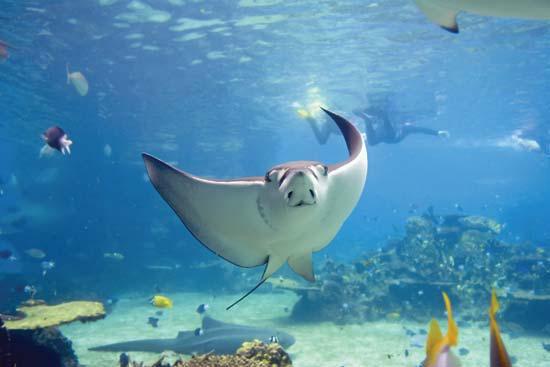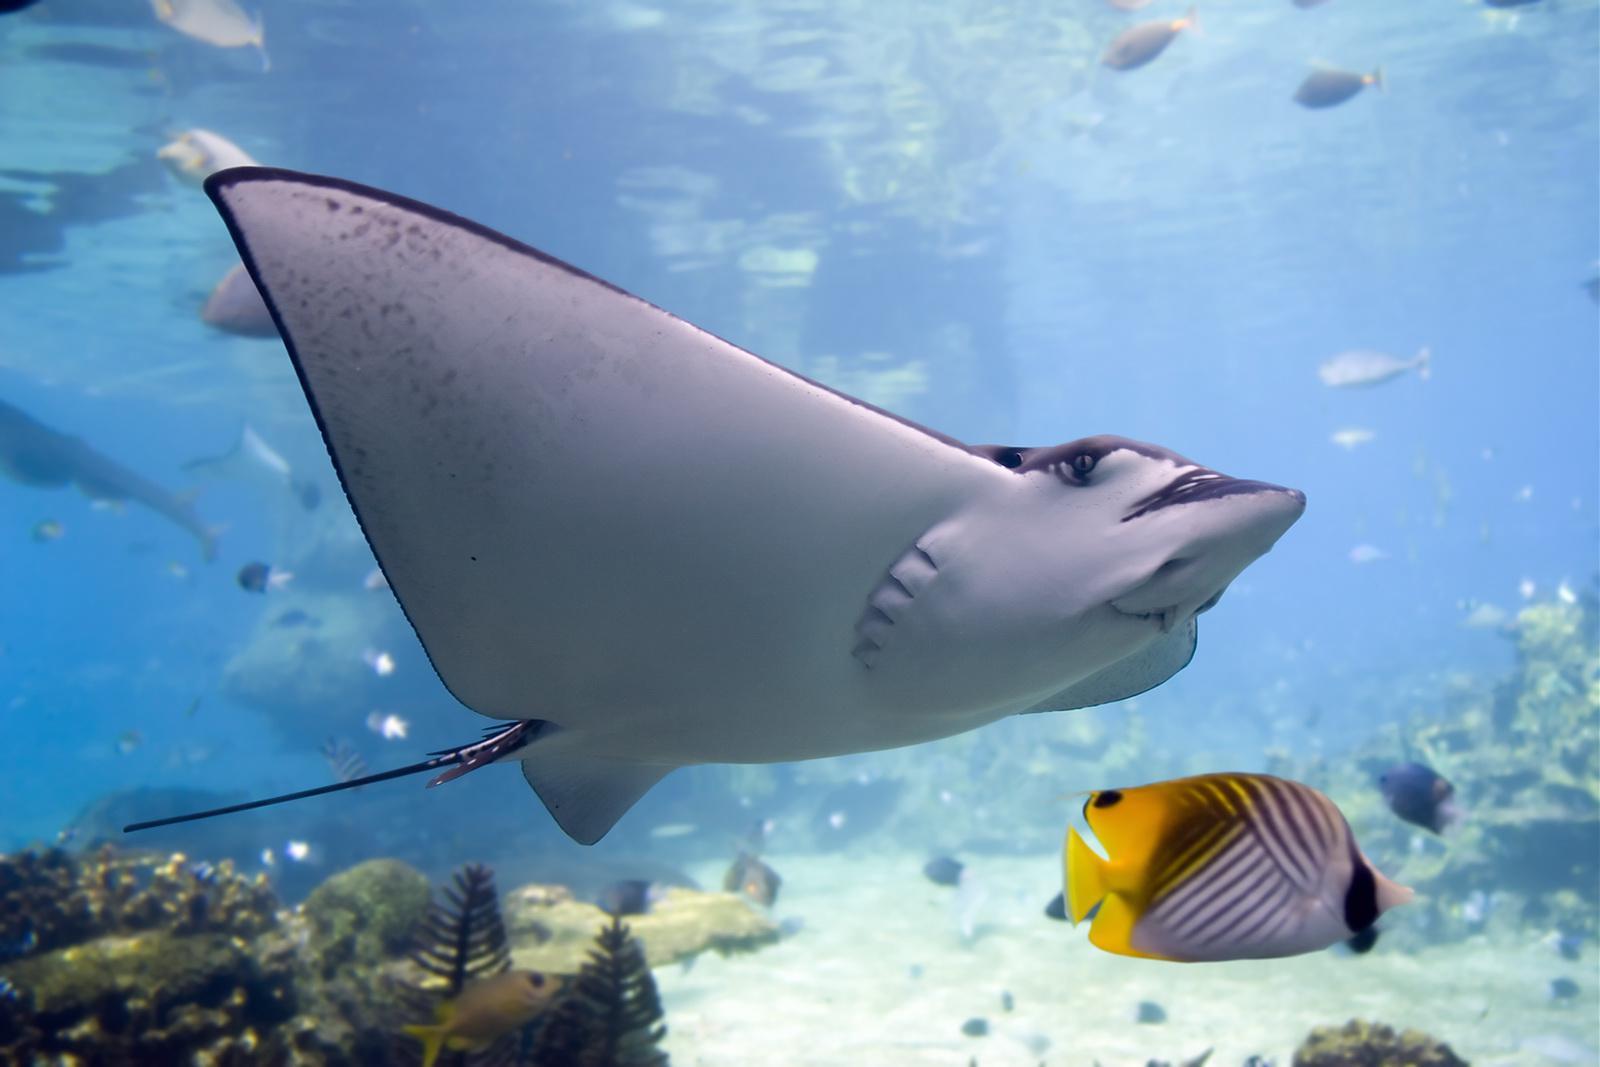The first image is the image on the left, the second image is the image on the right. Examine the images to the left and right. Is the description "An image shows one stingray, which is partly submerged in sand." accurate? Answer yes or no. No. The first image is the image on the left, the second image is the image on the right. Considering the images on both sides, is "The ray in the image on the left is partially under the sand." valid? Answer yes or no. No. 